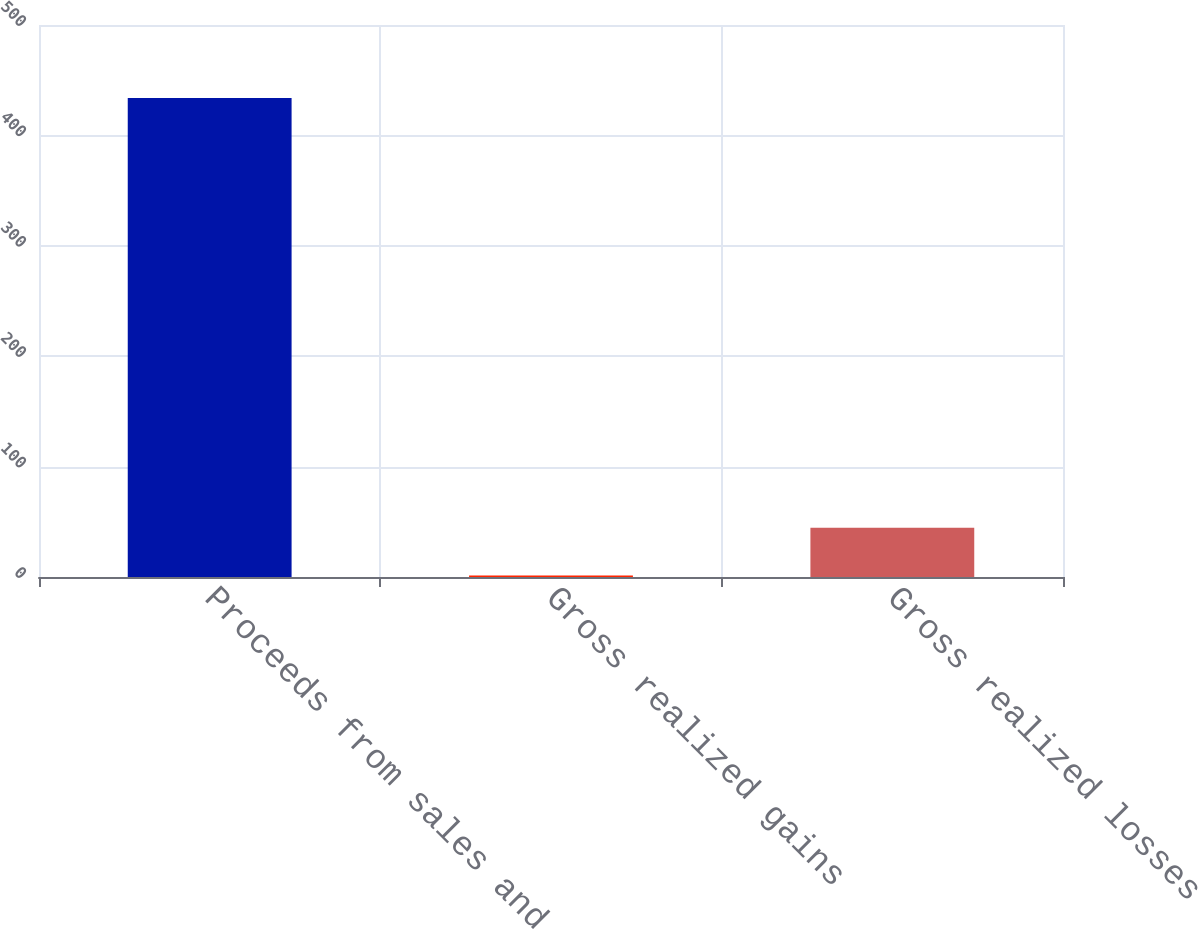<chart> <loc_0><loc_0><loc_500><loc_500><bar_chart><fcel>Proceeds from sales and<fcel>Gross realized gains<fcel>Gross realized losses<nl><fcel>433.9<fcel>1.3<fcel>44.56<nl></chart> 